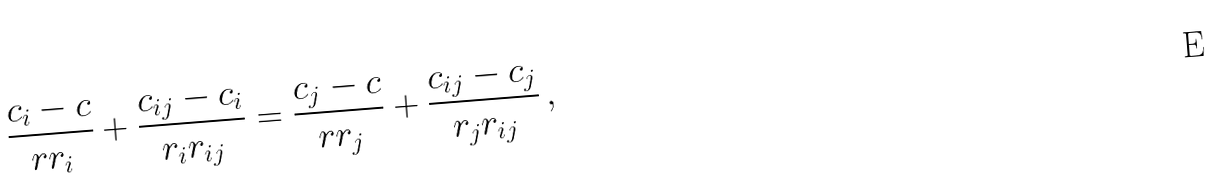Convert formula to latex. <formula><loc_0><loc_0><loc_500><loc_500>\frac { c _ { i } - c } { r r _ { i } } + \frac { c _ { i j } - c _ { i } } { r _ { i } r _ { i j } } = \frac { c _ { j } - c } { r r _ { j } } + \frac { c _ { i j } - c _ { j } } { r _ { j } r _ { i j } } \, ,</formula> 